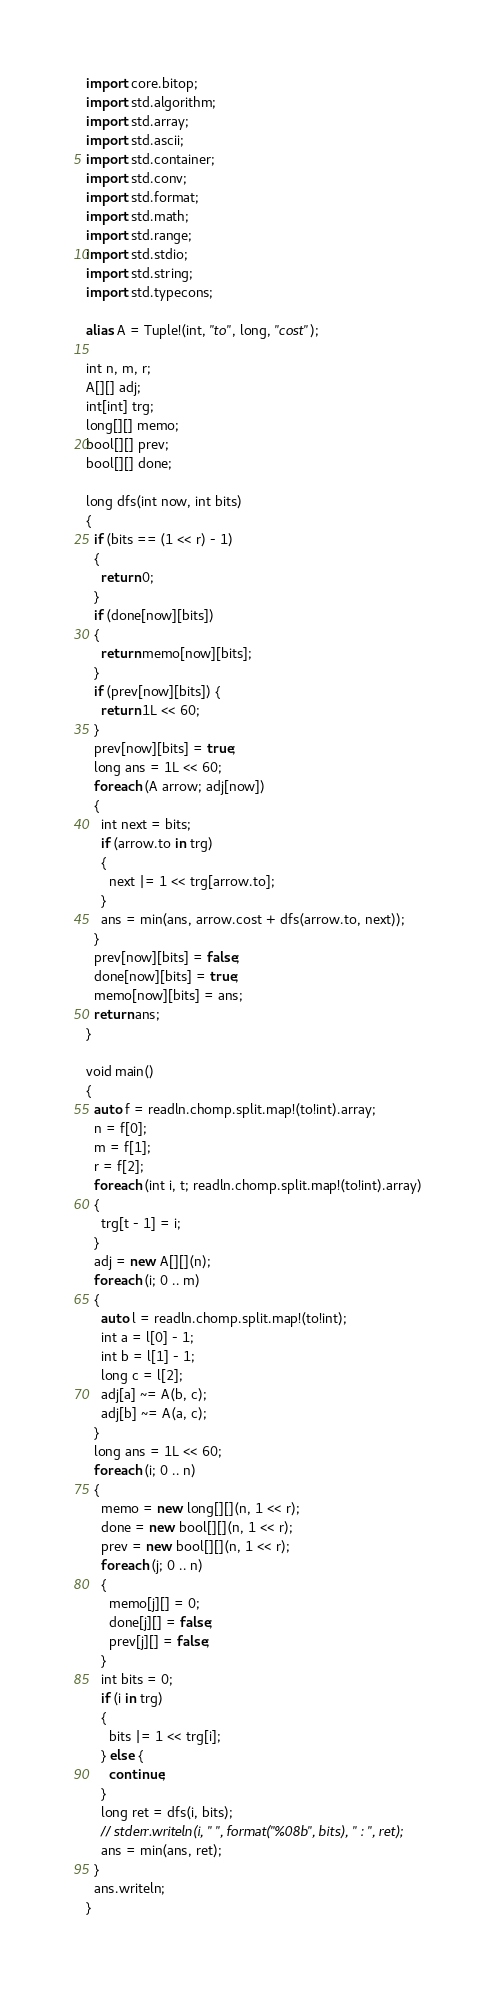<code> <loc_0><loc_0><loc_500><loc_500><_D_>import core.bitop;
import std.algorithm;
import std.array;
import std.ascii;
import std.container;
import std.conv;
import std.format;
import std.math;
import std.range;
import std.stdio;
import std.string;
import std.typecons;

alias A = Tuple!(int, "to", long, "cost");

int n, m, r;
A[][] adj;
int[int] trg;
long[][] memo;
bool[][] prev;
bool[][] done;

long dfs(int now, int bits)
{
  if (bits == (1 << r) - 1)
  {
    return 0;
  }
  if (done[now][bits])
  {
    return memo[now][bits];
  }
  if (prev[now][bits]) {
    return 1L << 60;
  }
  prev[now][bits] = true;
  long ans = 1L << 60;
  foreach (A arrow; adj[now])
  {
    int next = bits;
    if (arrow.to in trg)
    {
      next |= 1 << trg[arrow.to];
    }
    ans = min(ans, arrow.cost + dfs(arrow.to, next));
  }
  prev[now][bits] = false;
  done[now][bits] = true;
  memo[now][bits] = ans;
  return ans;
}

void main()
{
  auto f = readln.chomp.split.map!(to!int).array;
  n = f[0];
  m = f[1];
  r = f[2];
  foreach (int i, t; readln.chomp.split.map!(to!int).array)
  {
    trg[t - 1] = i;
  }
  adj = new A[][](n);
  foreach (i; 0 .. m)
  {
    auto l = readln.chomp.split.map!(to!int);
    int a = l[0] - 1;
    int b = l[1] - 1;
    long c = l[2];
    adj[a] ~= A(b, c);
    adj[b] ~= A(a, c);
  }
  long ans = 1L << 60;
  foreach (i; 0 .. n)
  {
    memo = new long[][](n, 1 << r);
    done = new bool[][](n, 1 << r);
    prev = new bool[][](n, 1 << r);
    foreach (j; 0 .. n)
    {
      memo[j][] = 0;
      done[j][] = false;
      prev[j][] = false;
    }
    int bits = 0;
    if (i in trg)
    {
      bits |= 1 << trg[i];
    } else {
      continue;
    }
    long ret = dfs(i, bits);
    // stderr.writeln(i, " ", format("%08b", bits), " : ", ret);
    ans = min(ans, ret);
  }
  ans.writeln;
}
</code> 